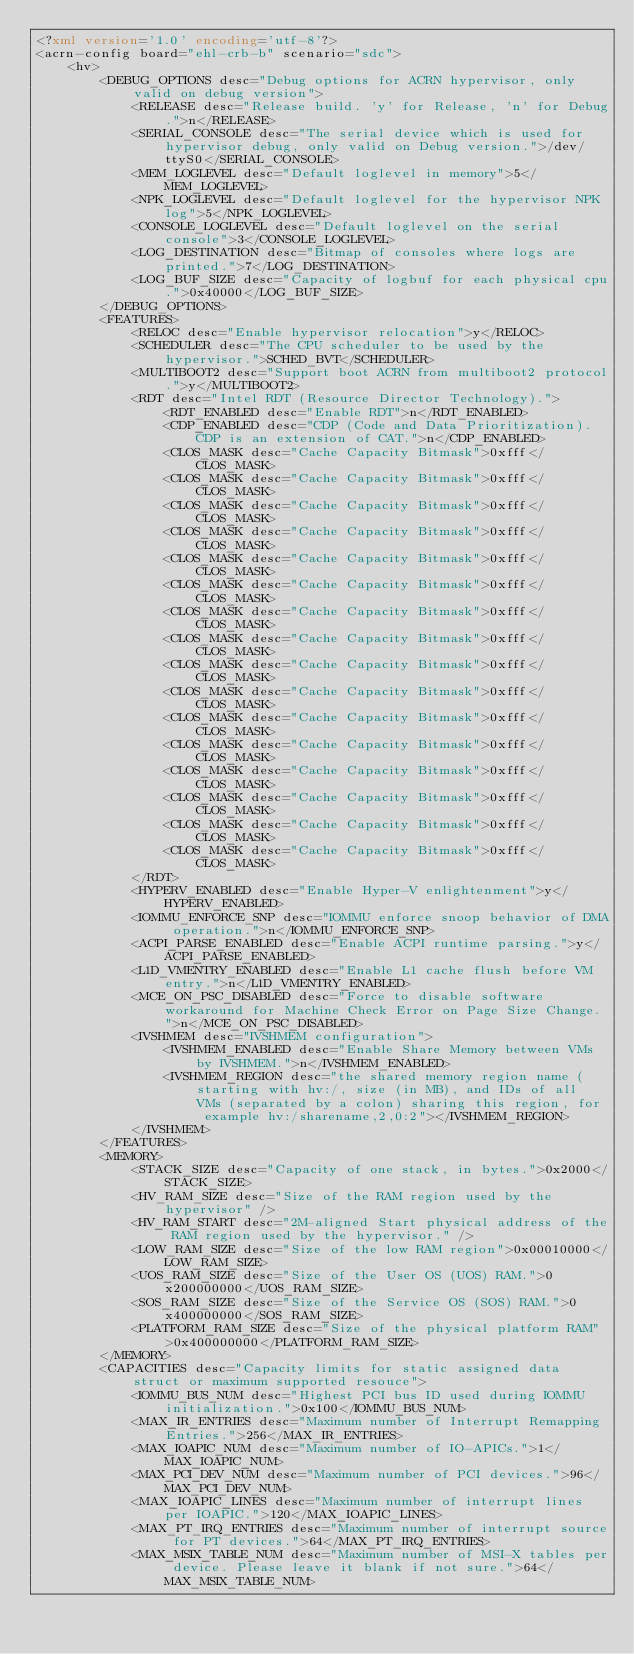<code> <loc_0><loc_0><loc_500><loc_500><_XML_><?xml version='1.0' encoding='utf-8'?>
<acrn-config board="ehl-crb-b" scenario="sdc">
    <hv>
        <DEBUG_OPTIONS desc="Debug options for ACRN hypervisor, only valid on debug version">
            <RELEASE desc="Release build. 'y' for Release, 'n' for Debug.">n</RELEASE>
            <SERIAL_CONSOLE desc="The serial device which is used for hypervisor debug, only valid on Debug version.">/dev/ttyS0</SERIAL_CONSOLE>
            <MEM_LOGLEVEL desc="Default loglevel in memory">5</MEM_LOGLEVEL>
            <NPK_LOGLEVEL desc="Default loglevel for the hypervisor NPK log">5</NPK_LOGLEVEL>
            <CONSOLE_LOGLEVEL desc="Default loglevel on the serial console">3</CONSOLE_LOGLEVEL>
            <LOG_DESTINATION desc="Bitmap of consoles where logs are printed.">7</LOG_DESTINATION>
            <LOG_BUF_SIZE desc="Capacity of logbuf for each physical cpu.">0x40000</LOG_BUF_SIZE>
        </DEBUG_OPTIONS>
        <FEATURES>
            <RELOC desc="Enable hypervisor relocation">y</RELOC>
            <SCHEDULER desc="The CPU scheduler to be used by the hypervisor.">SCHED_BVT</SCHEDULER>
            <MULTIBOOT2 desc="Support boot ACRN from multiboot2 protocol.">y</MULTIBOOT2>
            <RDT desc="Intel RDT (Resource Director Technology).">
                <RDT_ENABLED desc="Enable RDT">n</RDT_ENABLED>
                <CDP_ENABLED desc="CDP (Code and Data Prioritization). CDP is an extension of CAT.">n</CDP_ENABLED>
                <CLOS_MASK desc="Cache Capacity Bitmask">0xfff</CLOS_MASK>
                <CLOS_MASK desc="Cache Capacity Bitmask">0xfff</CLOS_MASK>
                <CLOS_MASK desc="Cache Capacity Bitmask">0xfff</CLOS_MASK>
                <CLOS_MASK desc="Cache Capacity Bitmask">0xfff</CLOS_MASK>
                <CLOS_MASK desc="Cache Capacity Bitmask">0xfff</CLOS_MASK>
                <CLOS_MASK desc="Cache Capacity Bitmask">0xfff</CLOS_MASK>
                <CLOS_MASK desc="Cache Capacity Bitmask">0xfff</CLOS_MASK>
                <CLOS_MASK desc="Cache Capacity Bitmask">0xfff</CLOS_MASK>
                <CLOS_MASK desc="Cache Capacity Bitmask">0xfff</CLOS_MASK>
                <CLOS_MASK desc="Cache Capacity Bitmask">0xfff</CLOS_MASK>
                <CLOS_MASK desc="Cache Capacity Bitmask">0xfff</CLOS_MASK>
                <CLOS_MASK desc="Cache Capacity Bitmask">0xfff</CLOS_MASK>
                <CLOS_MASK desc="Cache Capacity Bitmask">0xfff</CLOS_MASK>
                <CLOS_MASK desc="Cache Capacity Bitmask">0xfff</CLOS_MASK>
                <CLOS_MASK desc="Cache Capacity Bitmask">0xfff</CLOS_MASK>
                <CLOS_MASK desc="Cache Capacity Bitmask">0xfff</CLOS_MASK>
            </RDT>
            <HYPERV_ENABLED desc="Enable Hyper-V enlightenment">y</HYPERV_ENABLED>
            <IOMMU_ENFORCE_SNP desc="IOMMU enforce snoop behavior of DMA operation.">n</IOMMU_ENFORCE_SNP>
            <ACPI_PARSE_ENABLED desc="Enable ACPI runtime parsing.">y</ACPI_PARSE_ENABLED>
            <L1D_VMENTRY_ENABLED desc="Enable L1 cache flush before VM entry.">n</L1D_VMENTRY_ENABLED>
            <MCE_ON_PSC_DISABLED desc="Force to disable software workaround for Machine Check Error on Page Size Change.">n</MCE_ON_PSC_DISABLED>
            <IVSHMEM desc="IVSHMEM configuration">
                <IVSHMEM_ENABLED desc="Enable Share Memory between VMs by IVSHMEM.">n</IVSHMEM_ENABLED>
                <IVSHMEM_REGION desc="the shared memory region name (starting with hv:/, size (in MB), and IDs of all VMs (separated by a colon) sharing this region, for example hv:/sharename,2,0:2"></IVSHMEM_REGION>
            </IVSHMEM>
        </FEATURES>
        <MEMORY>
            <STACK_SIZE desc="Capacity of one stack, in bytes.">0x2000</STACK_SIZE>
            <HV_RAM_SIZE desc="Size of the RAM region used by the hypervisor" />
            <HV_RAM_START desc="2M-aligned Start physical address of the RAM region used by the hypervisor." />
            <LOW_RAM_SIZE desc="Size of the low RAM region">0x00010000</LOW_RAM_SIZE>
            <UOS_RAM_SIZE desc="Size of the User OS (UOS) RAM.">0x200000000</UOS_RAM_SIZE>
            <SOS_RAM_SIZE desc="Size of the Service OS (SOS) RAM.">0x400000000</SOS_RAM_SIZE>
            <PLATFORM_RAM_SIZE desc="Size of the physical platform RAM">0x400000000</PLATFORM_RAM_SIZE>
        </MEMORY>
        <CAPACITIES desc="Capacity limits for static assigned data struct or maximum supported resouce">
            <IOMMU_BUS_NUM desc="Highest PCI bus ID used during IOMMU initialization.">0x100</IOMMU_BUS_NUM>
            <MAX_IR_ENTRIES desc="Maximum number of Interrupt Remapping Entries.">256</MAX_IR_ENTRIES>
            <MAX_IOAPIC_NUM desc="Maximum number of IO-APICs.">1</MAX_IOAPIC_NUM>
            <MAX_PCI_DEV_NUM desc="Maximum number of PCI devices.">96</MAX_PCI_DEV_NUM>
            <MAX_IOAPIC_LINES desc="Maximum number of interrupt lines per IOAPIC.">120</MAX_IOAPIC_LINES>
            <MAX_PT_IRQ_ENTRIES desc="Maximum number of interrupt source for PT devices.">64</MAX_PT_IRQ_ENTRIES>
            <MAX_MSIX_TABLE_NUM desc="Maximum number of MSI-X tables per device. Please leave it blank if not sure.">64</MAX_MSIX_TABLE_NUM></code> 